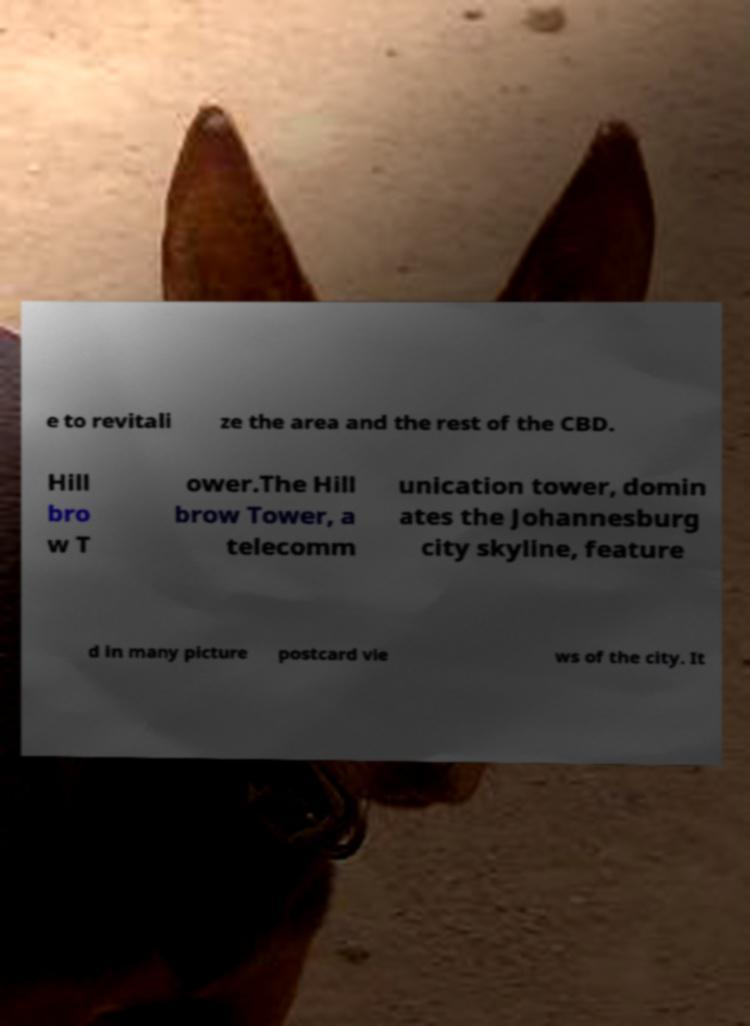Could you assist in decoding the text presented in this image and type it out clearly? e to revitali ze the area and the rest of the CBD. Hill bro w T ower.The Hill brow Tower, a telecomm unication tower, domin ates the Johannesburg city skyline, feature d in many picture postcard vie ws of the city. It 